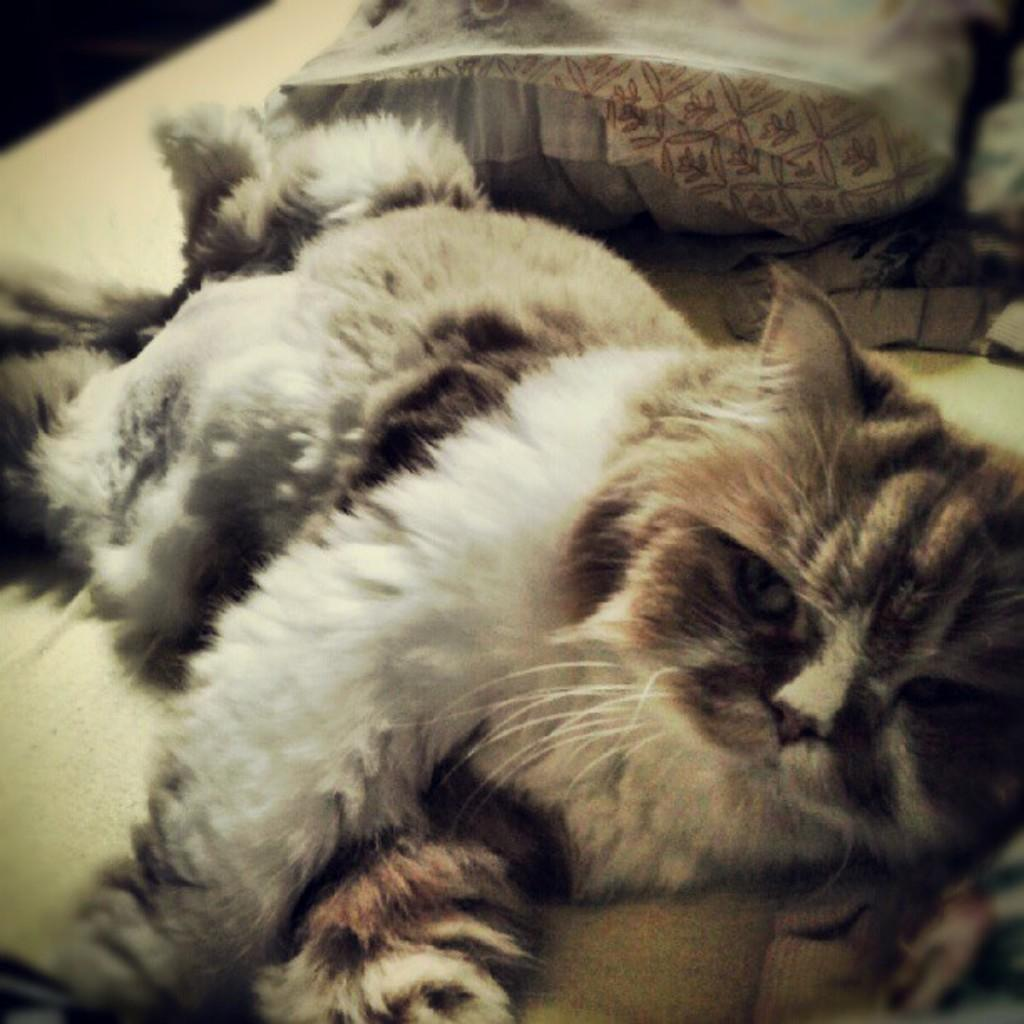What type of animal is present in the image? There is a cat in the image. What is the cat doing in the image? The cat is sleeping on the bed. What else can be seen on the bed in the image? There are pillows and blankets in the image. What type of brass instrument can be heard playing in the background of the image? There is no brass instrument or sound present in the image; it only features a cat sleeping on the bed and some bedding. 